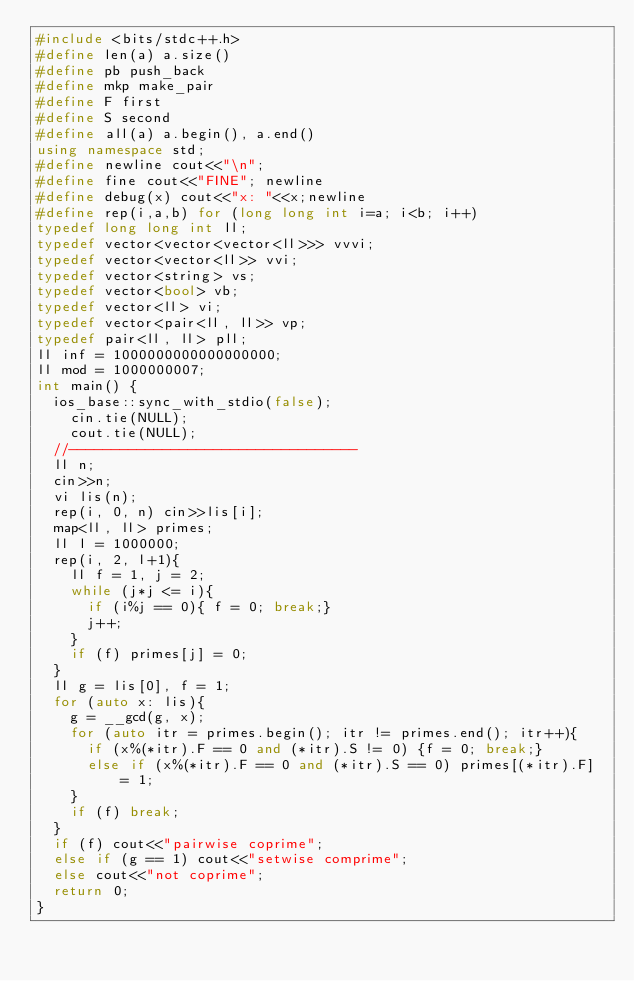<code> <loc_0><loc_0><loc_500><loc_500><_C++_>#include <bits/stdc++.h>
#define len(a) a.size()
#define pb push_back
#define mkp make_pair
#define F first
#define S second
#define all(a) a.begin(), a.end()
using namespace std;
#define newline cout<<"\n";
#define fine cout<<"FINE"; newline
#define debug(x) cout<<"x: "<<x;newline
#define rep(i,a,b) for (long long int i=a; i<b; i++)
typedef long long int ll;
typedef vector<vector<vector<ll>>> vvvi;
typedef vector<vector<ll>> vvi;
typedef vector<string> vs;
typedef vector<bool> vb;
typedef vector<ll> vi;
typedef vector<pair<ll, ll>> vp;
typedef pair<ll, ll> pll;
ll inf = 1000000000000000000;
ll mod = 1000000007;
int main() {
	ios_base::sync_with_stdio(false);
    cin.tie(NULL);
    cout.tie(NULL);
	//----------------------------------
	ll n;
	cin>>n;
	vi lis(n);
	rep(i, 0, n) cin>>lis[i];
	map<ll, ll> primes;
	ll l = 1000000;
	rep(i, 2, l+1){
		ll f = 1, j = 2;
		while (j*j <= i){
			if (i%j == 0){ f = 0; break;}
			j++;
		}
		if (f) primes[j] = 0;
	}
	ll g = lis[0], f = 1;
	for (auto x: lis){
		g = __gcd(g, x);
		for (auto itr = primes.begin(); itr != primes.end(); itr++){
			if (x%(*itr).F == 0 and (*itr).S != 0) {f = 0; break;}
			else if (x%(*itr).F == 0 and (*itr).S == 0) primes[(*itr).F] = 1;
		}
		if (f) break;
	}
	if (f) cout<<"pairwise coprime";
	else if (g == 1) cout<<"setwise comprime";
	else cout<<"not coprime";
	return 0;
}</code> 